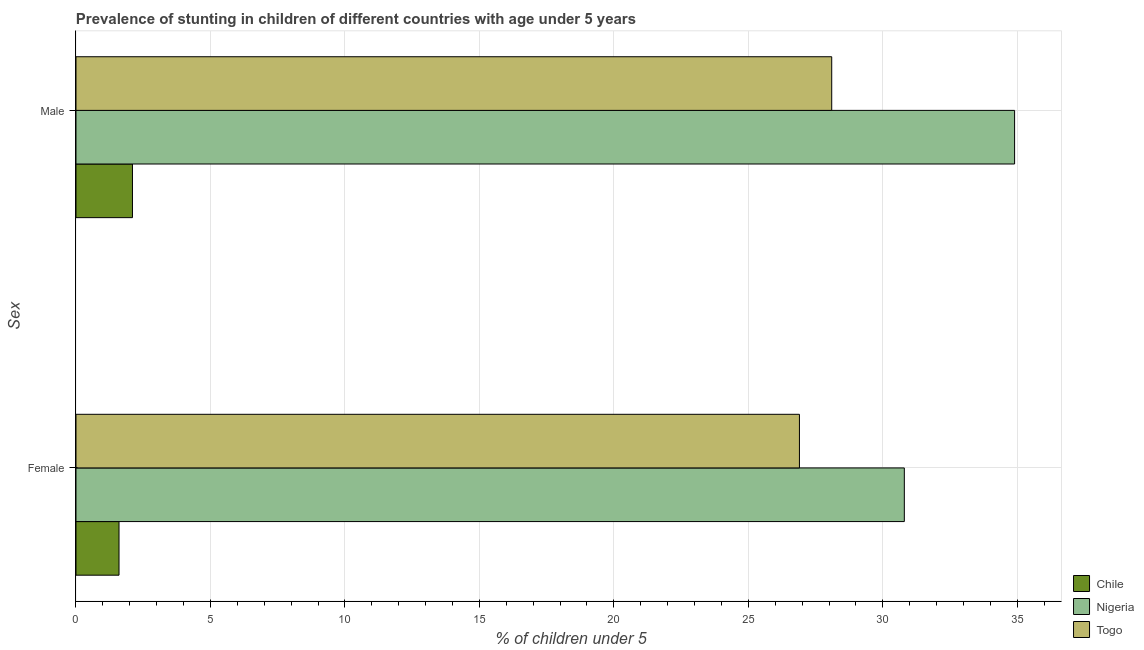How many different coloured bars are there?
Offer a very short reply. 3. Are the number of bars per tick equal to the number of legend labels?
Your response must be concise. Yes. How many bars are there on the 1st tick from the top?
Provide a succinct answer. 3. How many bars are there on the 1st tick from the bottom?
Offer a very short reply. 3. What is the label of the 2nd group of bars from the top?
Make the answer very short. Female. What is the percentage of stunted male children in Chile?
Provide a short and direct response. 2.1. Across all countries, what is the maximum percentage of stunted male children?
Give a very brief answer. 34.9. Across all countries, what is the minimum percentage of stunted female children?
Offer a terse response. 1.6. In which country was the percentage of stunted male children maximum?
Your answer should be very brief. Nigeria. In which country was the percentage of stunted male children minimum?
Offer a terse response. Chile. What is the total percentage of stunted female children in the graph?
Make the answer very short. 59.3. What is the difference between the percentage of stunted male children in Togo and that in Chile?
Offer a very short reply. 26. What is the difference between the percentage of stunted male children in Togo and the percentage of stunted female children in Nigeria?
Offer a very short reply. -2.7. What is the average percentage of stunted male children per country?
Offer a terse response. 21.7. What is the difference between the percentage of stunted female children and percentage of stunted male children in Chile?
Your answer should be compact. -0.5. In how many countries, is the percentage of stunted female children greater than 25 %?
Keep it short and to the point. 2. What is the ratio of the percentage of stunted female children in Chile to that in Nigeria?
Give a very brief answer. 0.05. Is the percentage of stunted male children in Togo less than that in Nigeria?
Provide a succinct answer. Yes. In how many countries, is the percentage of stunted female children greater than the average percentage of stunted female children taken over all countries?
Give a very brief answer. 2. What does the 3rd bar from the bottom in Male represents?
Give a very brief answer. Togo. How many bars are there?
Offer a terse response. 6. Does the graph contain grids?
Give a very brief answer. Yes. Where does the legend appear in the graph?
Give a very brief answer. Bottom right. How many legend labels are there?
Keep it short and to the point. 3. What is the title of the graph?
Offer a terse response. Prevalence of stunting in children of different countries with age under 5 years. Does "Macao" appear as one of the legend labels in the graph?
Offer a very short reply. No. What is the label or title of the X-axis?
Your response must be concise.  % of children under 5. What is the label or title of the Y-axis?
Your answer should be very brief. Sex. What is the  % of children under 5 in Chile in Female?
Your answer should be very brief. 1.6. What is the  % of children under 5 in Nigeria in Female?
Your answer should be very brief. 30.8. What is the  % of children under 5 in Togo in Female?
Give a very brief answer. 26.9. What is the  % of children under 5 in Chile in Male?
Make the answer very short. 2.1. What is the  % of children under 5 of Nigeria in Male?
Offer a very short reply. 34.9. What is the  % of children under 5 in Togo in Male?
Offer a terse response. 28.1. Across all Sex, what is the maximum  % of children under 5 in Chile?
Ensure brevity in your answer.  2.1. Across all Sex, what is the maximum  % of children under 5 of Nigeria?
Provide a short and direct response. 34.9. Across all Sex, what is the maximum  % of children under 5 in Togo?
Offer a terse response. 28.1. Across all Sex, what is the minimum  % of children under 5 in Chile?
Provide a short and direct response. 1.6. Across all Sex, what is the minimum  % of children under 5 of Nigeria?
Provide a short and direct response. 30.8. Across all Sex, what is the minimum  % of children under 5 of Togo?
Make the answer very short. 26.9. What is the total  % of children under 5 of Nigeria in the graph?
Provide a short and direct response. 65.7. What is the difference between the  % of children under 5 in Chile in Female and that in Male?
Provide a short and direct response. -0.5. What is the difference between the  % of children under 5 in Nigeria in Female and that in Male?
Make the answer very short. -4.1. What is the difference between the  % of children under 5 of Togo in Female and that in Male?
Your response must be concise. -1.2. What is the difference between the  % of children under 5 in Chile in Female and the  % of children under 5 in Nigeria in Male?
Offer a very short reply. -33.3. What is the difference between the  % of children under 5 of Chile in Female and the  % of children under 5 of Togo in Male?
Make the answer very short. -26.5. What is the average  % of children under 5 of Chile per Sex?
Provide a succinct answer. 1.85. What is the average  % of children under 5 in Nigeria per Sex?
Provide a short and direct response. 32.85. What is the difference between the  % of children under 5 of Chile and  % of children under 5 of Nigeria in Female?
Offer a terse response. -29.2. What is the difference between the  % of children under 5 of Chile and  % of children under 5 of Togo in Female?
Offer a very short reply. -25.3. What is the difference between the  % of children under 5 in Nigeria and  % of children under 5 in Togo in Female?
Offer a very short reply. 3.9. What is the difference between the  % of children under 5 in Chile and  % of children under 5 in Nigeria in Male?
Provide a succinct answer. -32.8. What is the difference between the  % of children under 5 in Chile and  % of children under 5 in Togo in Male?
Provide a succinct answer. -26. What is the ratio of the  % of children under 5 of Chile in Female to that in Male?
Your response must be concise. 0.76. What is the ratio of the  % of children under 5 of Nigeria in Female to that in Male?
Provide a short and direct response. 0.88. What is the ratio of the  % of children under 5 of Togo in Female to that in Male?
Your answer should be very brief. 0.96. What is the difference between the highest and the second highest  % of children under 5 in Chile?
Give a very brief answer. 0.5. What is the difference between the highest and the second highest  % of children under 5 in Togo?
Keep it short and to the point. 1.2. What is the difference between the highest and the lowest  % of children under 5 in Chile?
Offer a very short reply. 0.5. What is the difference between the highest and the lowest  % of children under 5 of Togo?
Provide a succinct answer. 1.2. 